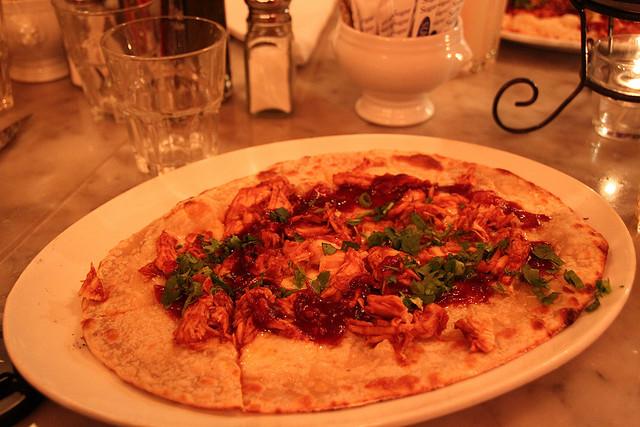Is this pizza sliced normally?
Write a very short answer. No. Is the glass empty?
Write a very short answer. Yes. How many slices are missing here?
Keep it brief. 0. What is the name of that food?
Concise answer only. Pizza. 